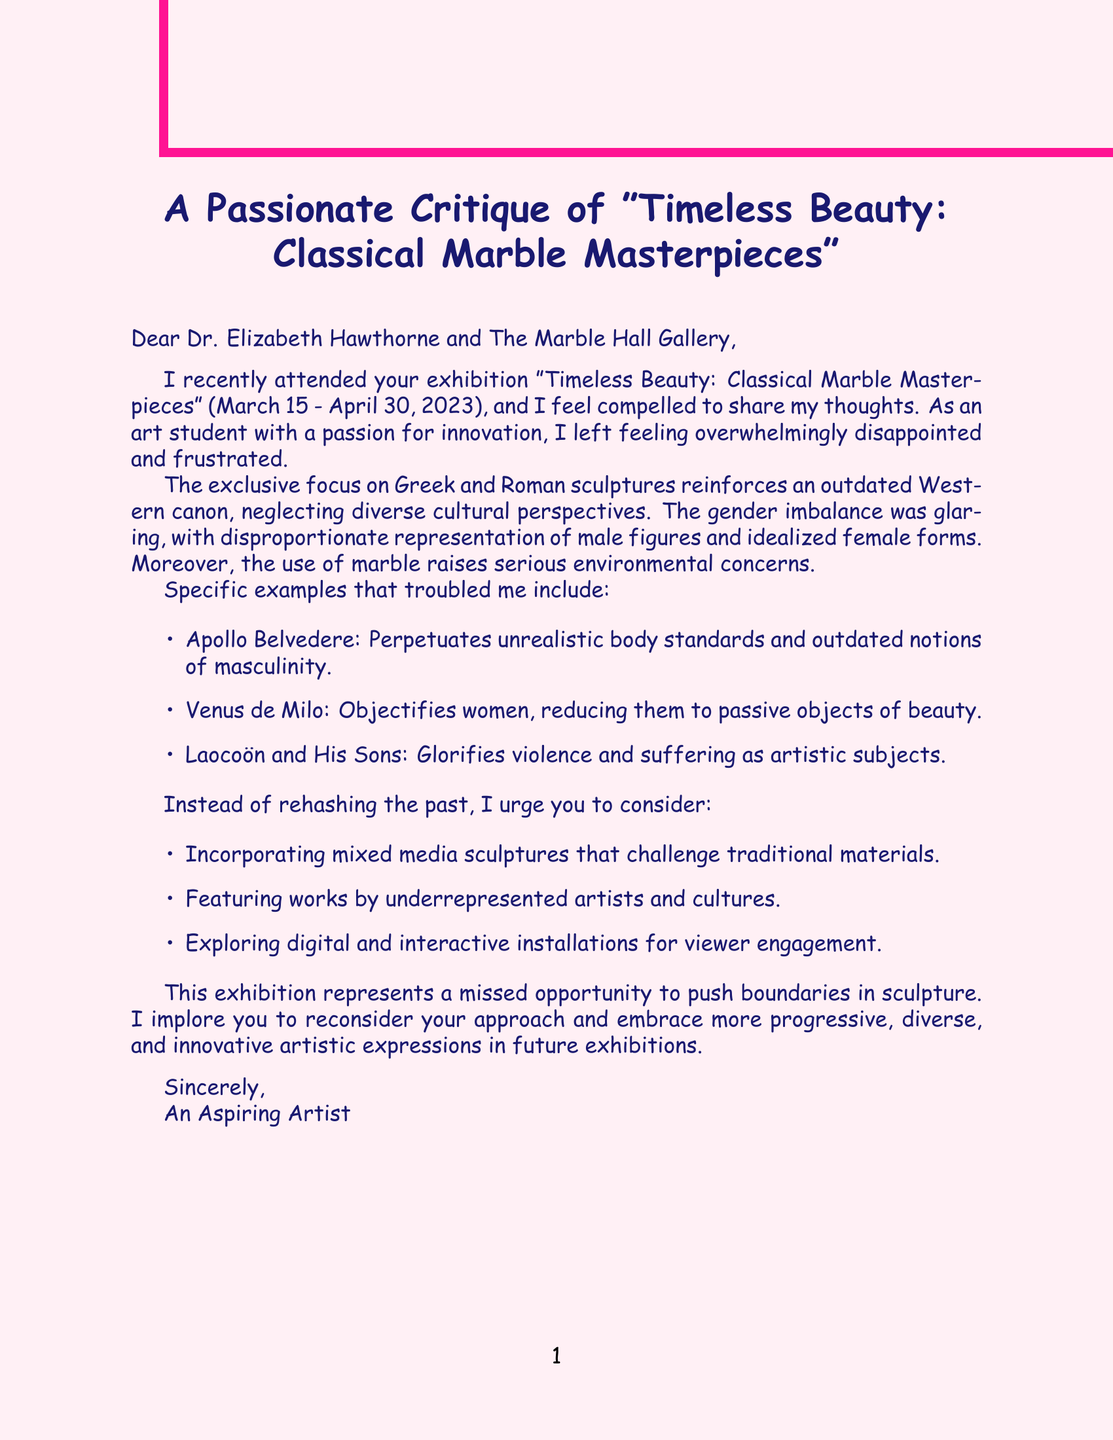What is the name of the gallery? The document mentions "The Marble Hall Gallery" as the name of the gallery.
Answer: The Marble Hall Gallery What is the exhibition title? The letter refers to the exhibition as "Timeless Beauty: Classical Marble Masterpieces."
Answer: Timeless Beauty: Classical Marble Masterpieces Who is the curator of the exhibition? The document states that the curator is Dr. Elizabeth Hawthorne.
Answer: Dr. Elizabeth Hawthorne What is the emotional response expressed by the author? The author expresses anger at the lack of innovation and creativity in the exhibition.
Answer: Anger at the lack of innovation and creativity What specific statue perpetuates unrealistic body standards? The author criticizes the "Apollo Belvedere" for perpetuating unrealistic body standards.
Answer: Apollo Belvedere What type of sculptures does the author suggest incorporating? The author suggests incorporating mixed media sculptures to challenge traditional materials.
Answer: Mixed media sculptures What aspect of representation is mentioned as disproportionate? The letter notes the gender imbalance as a key issue in representation.
Answer: Gender imbalance What dates was the exhibition open to the public? The document states that the exhibition was open from March 15 to April 30, 2023.
Answer: March 15 - April 30, 2023 What does the author urge the gallery to consider for future exhibitions? The author urges the gallery to embrace more progressive, diverse, and innovative artistic expressions for future exhibitions.
Answer: More progressive, diverse, and innovative artistic expressions 